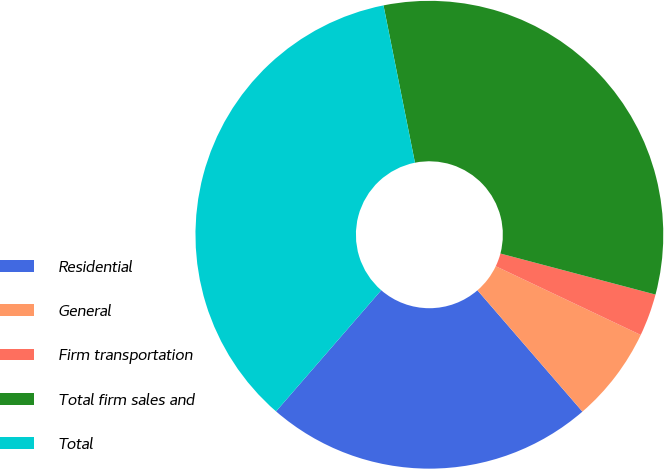Convert chart. <chart><loc_0><loc_0><loc_500><loc_500><pie_chart><fcel>Residential<fcel>General<fcel>Firm transportation<fcel>Total firm sales and<fcel>Total<nl><fcel>22.73%<fcel>6.6%<fcel>2.93%<fcel>32.26%<fcel>35.48%<nl></chart> 